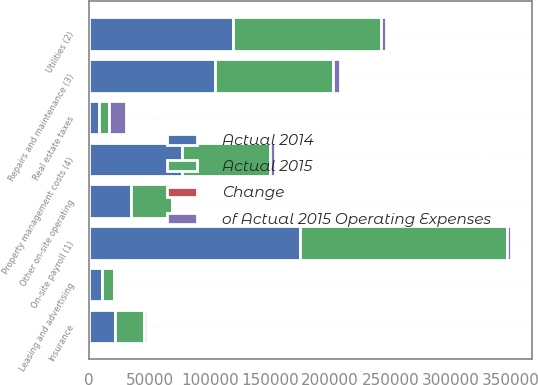Convert chart to OTSL. <chart><loc_0><loc_0><loc_500><loc_500><stacked_bar_chart><ecel><fcel>Real estate taxes<fcel>On-site payroll (1)<fcel>Utilities (2)<fcel>Repairs and maintenance (3)<fcel>Property management costs (4)<fcel>Insurance<fcel>Leasing and advertising<fcel>Other on-site operating<nl><fcel>Actual 2014<fcel>8117.5<fcel>174950<fcel>118986<fcel>104033<fcel>77001<fcel>21335<fcel>10370<fcel>34721<nl><fcel>Actual 2015<fcel>8117.5<fcel>171706<fcel>123296<fcel>98168<fcel>73242<fcel>23909<fcel>10605<fcel>33924<nl><fcel>of Actual 2015 Operating Expenses<fcel>13997<fcel>3244<fcel>4310<fcel>5865<fcel>3759<fcel>2574<fcel>235<fcel>797<nl><fcel>Change<fcel>35.4<fcel>20.9<fcel>14.2<fcel>12.4<fcel>9.2<fcel>2.6<fcel>1.2<fcel>4.1<nl></chart> 